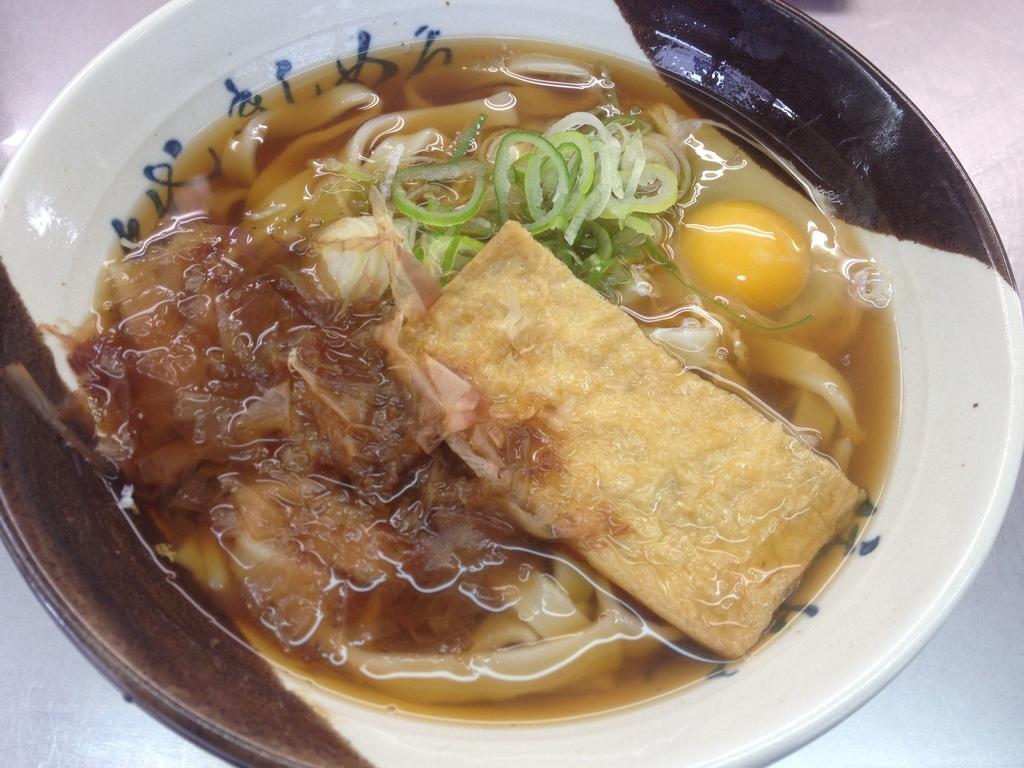In one or two sentences, can you explain what this image depicts? In this image I can see different types of food in this plate. I can see colour of this plate is white and little bit brown. 